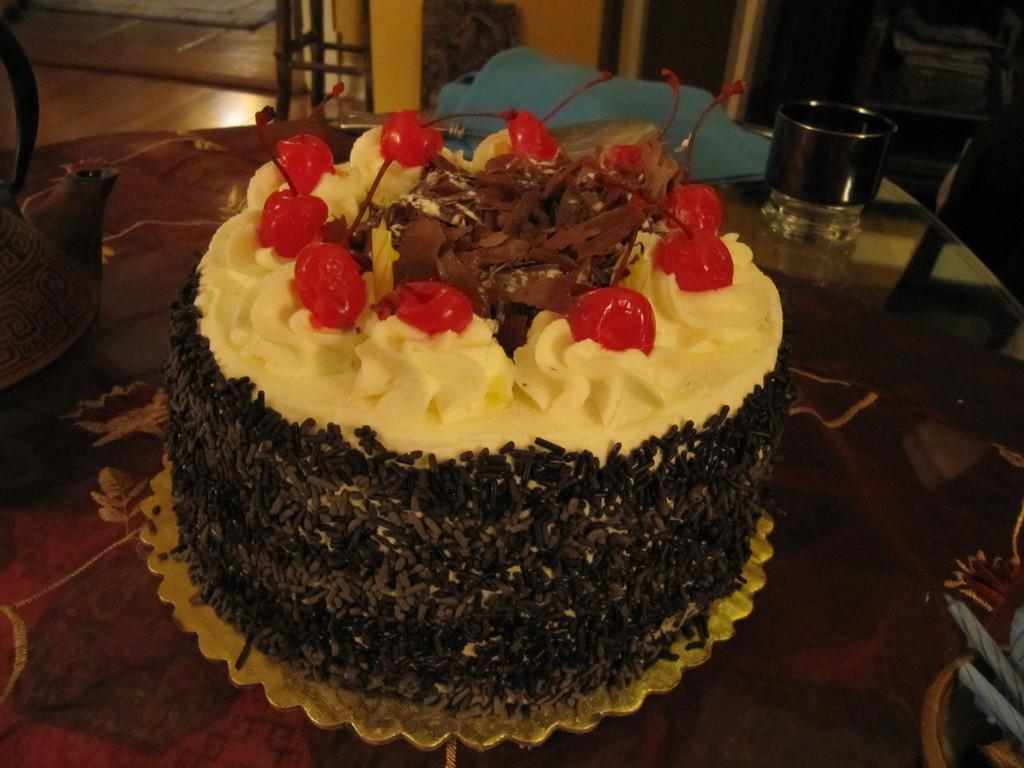What is the main object in the center of the image? There is a table in the center of the image. What is placed on the table? There is a cake and a glass on the table. What else can be seen on the table? There is also a jar on the table. What can be seen in the background of the image? There is a chair and a wall visible in the background of the image. What type of nail is being hammered into the wall in the image? There is no nail being hammered into the wall in the image; only a chair and a wall are visible in the background. What school is hosting the event in the image? There is no event or school mentioned or depicted in the image. 